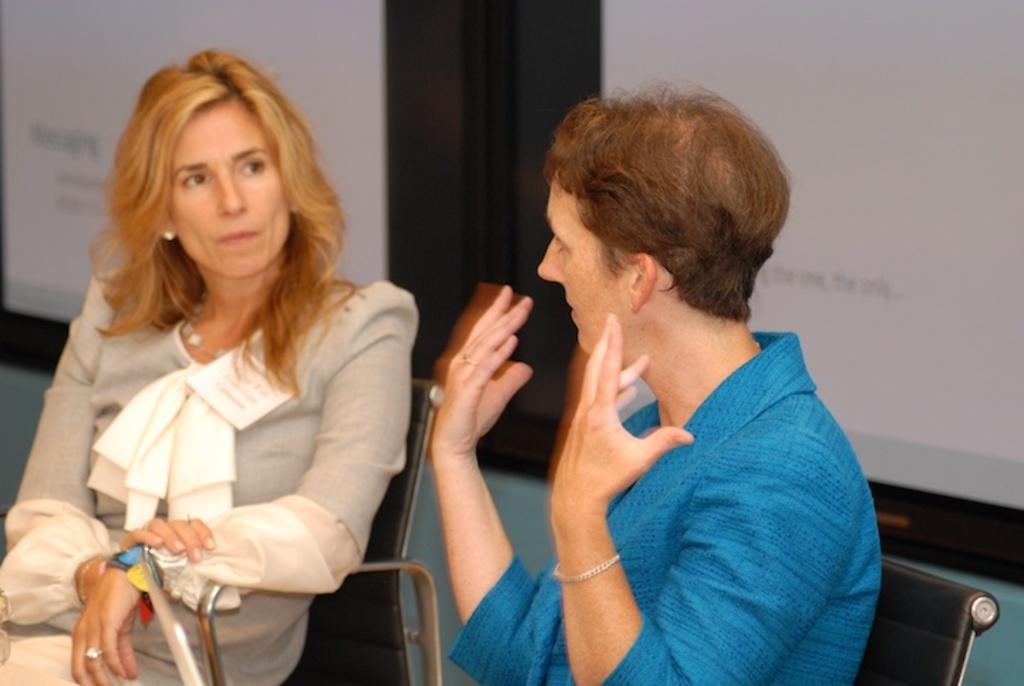How would you summarize this image in a sentence or two? In the image there are two women in golden hairs sitting on chairs talking and behind them there is wall, the woman in front wearing blue dress and the woman on left side wearing grey color dress. 